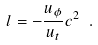<formula> <loc_0><loc_0><loc_500><loc_500>l = - \frac { u _ { \phi } } { u _ { t } } c ^ { 2 } \ .</formula> 